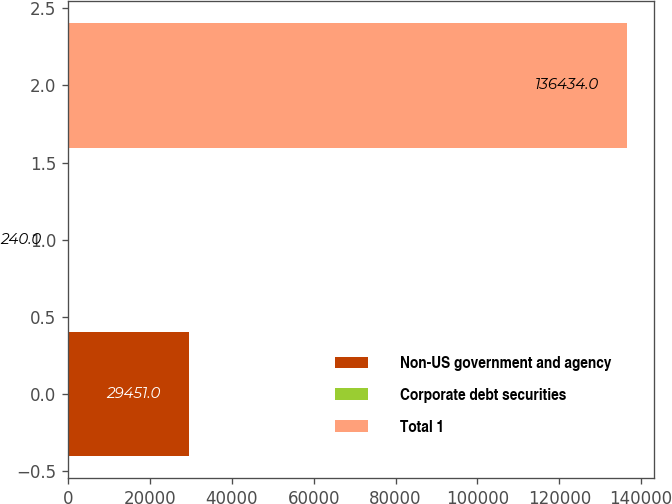Convert chart to OTSL. <chart><loc_0><loc_0><loc_500><loc_500><bar_chart><fcel>Non-US government and agency<fcel>Corporate debt securities<fcel>Total 1<nl><fcel>29451<fcel>240<fcel>136434<nl></chart> 